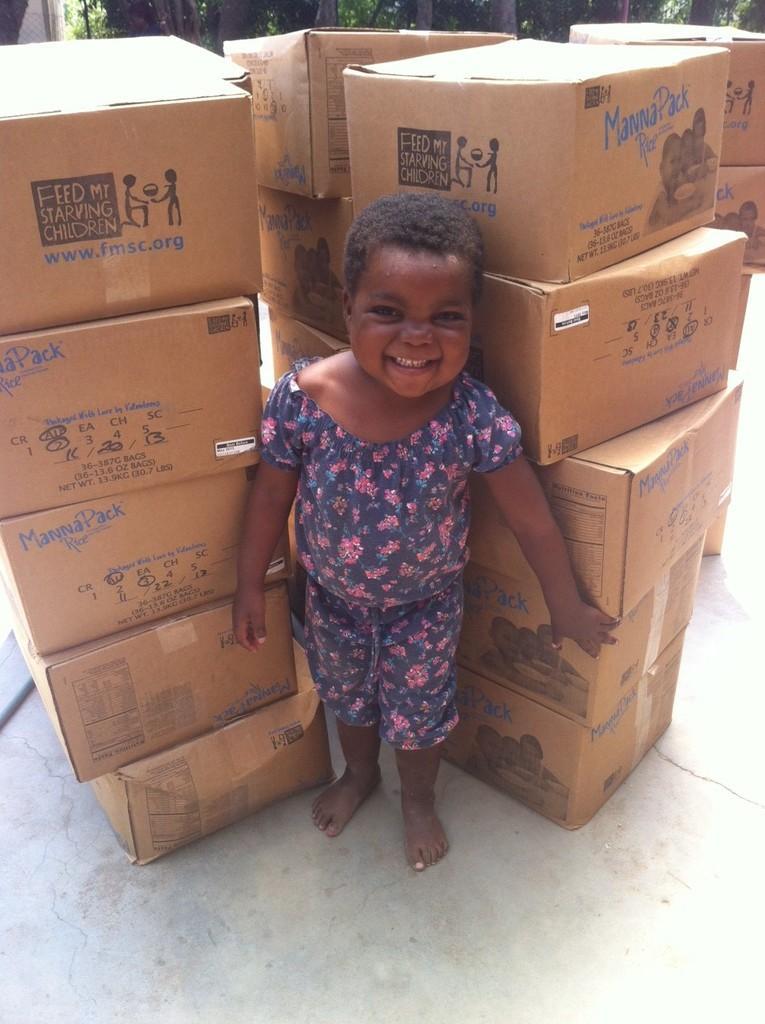In one or two sentences, can you explain what this image depicts? In this picture we can see a boy standing in front of the boxes. 